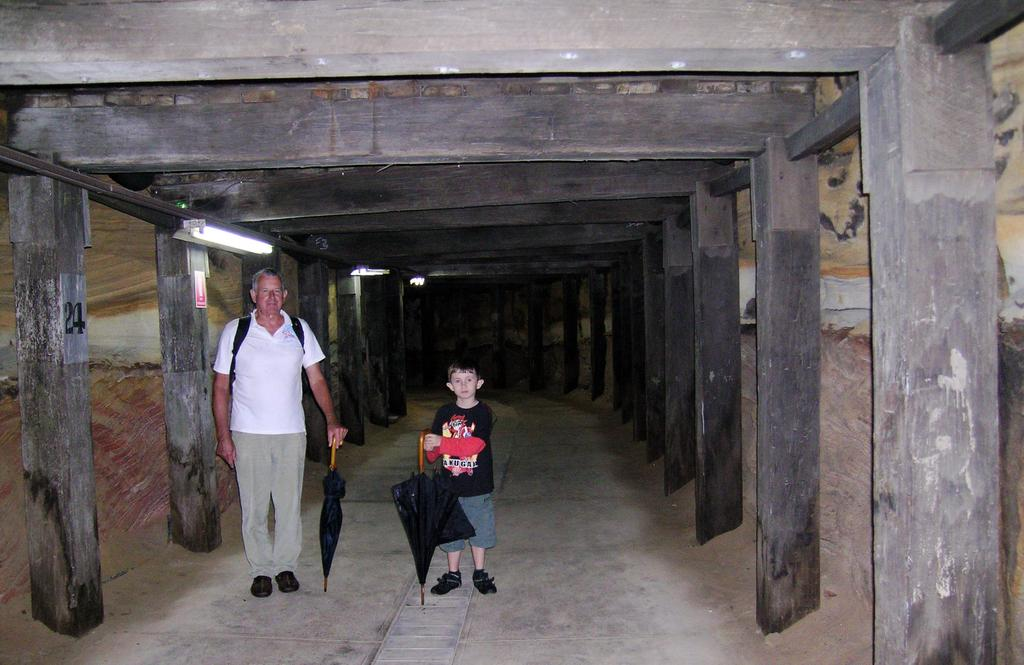Who is present in the image? There is a man and a boy in the image. What is the man carrying? The man is carrying a bag. What are the man and the boy holding? Both the man and the boy are holding umbrellas. What can be seen in the background of the image? There is a path, pillars, a wooden top, and a light in the image. How many clocks are visible in the image? There are no clocks visible in the image. What request is the man making to the boy in the image? There is no indication of a request being made in the image. 